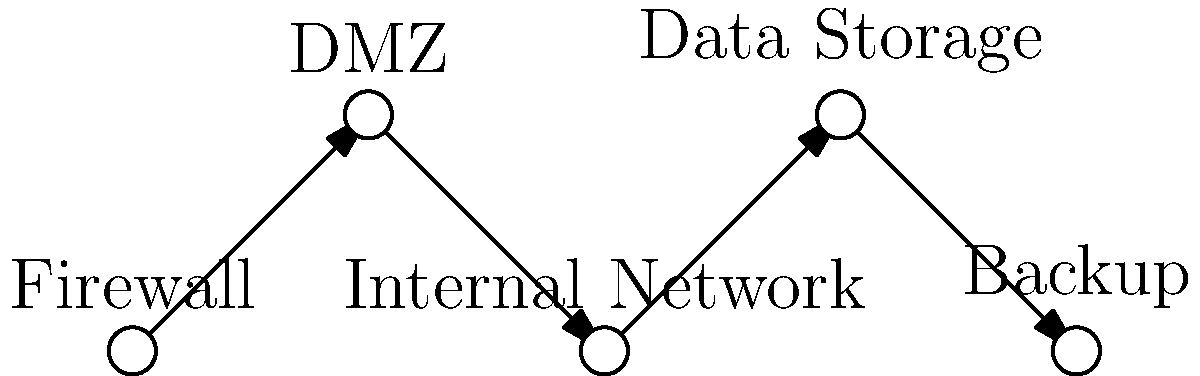In the secure network topology shown for a hospital's patient data system, which component should be placed between the firewall and the internal network to enhance security and act as a buffer zone? To understand the correct placement of components in a secure network topology for a hospital's patient data system, let's analyze the diagram and the role of each component:

1. Firewall: This is the first line of defense, filtering incoming and outgoing traffic.

2. DMZ (Demilitarized Zone): This is a neutral zone between the public internet and the private network, adding an extra layer of security.

3. Internal Network: This is where the hospital's internal systems and workstations reside.

4. Data Storage: This is where patient data is stored securely.

5. Backup: This ensures data redundancy and recovery capabilities.

The key to enhancing security is to place a buffer zone between the firewall and the internal network. This buffer zone is the DMZ, which acts as an intermediary between the public internet and the private internal network.

The DMZ hosts services that need to be accessible from the internet (like web servers) while keeping the internal network isolated. This configuration allows the firewall to be configured with stricter rules for traffic passing from the DMZ to the internal network, thus providing an additional layer of security for sensitive patient data.

In the diagram, we can see that the DMZ is correctly positioned between the Firewall and the Internal Network, fulfilling its role as a security buffer.
Answer: DMZ (Demilitarized Zone) 